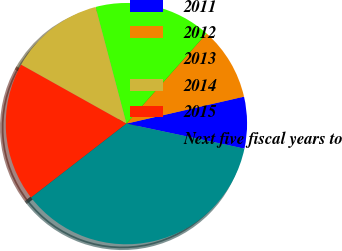Convert chart to OTSL. <chart><loc_0><loc_0><loc_500><loc_500><pie_chart><fcel>2011<fcel>2012<fcel>2013<fcel>2014<fcel>2015<fcel>Next five fiscal years to<nl><fcel>6.91%<fcel>9.84%<fcel>15.69%<fcel>12.76%<fcel>18.62%<fcel>36.18%<nl></chart> 